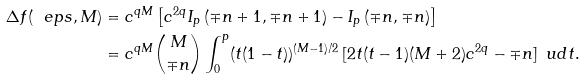<formula> <loc_0><loc_0><loc_500><loc_500>\Delta f ( \ e p s , M ) & = c ^ { q M } \left [ c ^ { 2 q } I _ { p } \left ( \mp n + 1 , \mp n + 1 \right ) - I _ { p } \left ( \mp n , \mp n \right ) \right ] \\ & = c ^ { q M } \binom { M } { \mp n } \int _ { 0 } ^ { p } ( t ( 1 - t ) ) ^ { ( M - 1 ) / 2 } \, [ 2 t ( t - 1 ) ( M + 2 ) c ^ { 2 q } - \mp n ] \, \ u d t .</formula> 